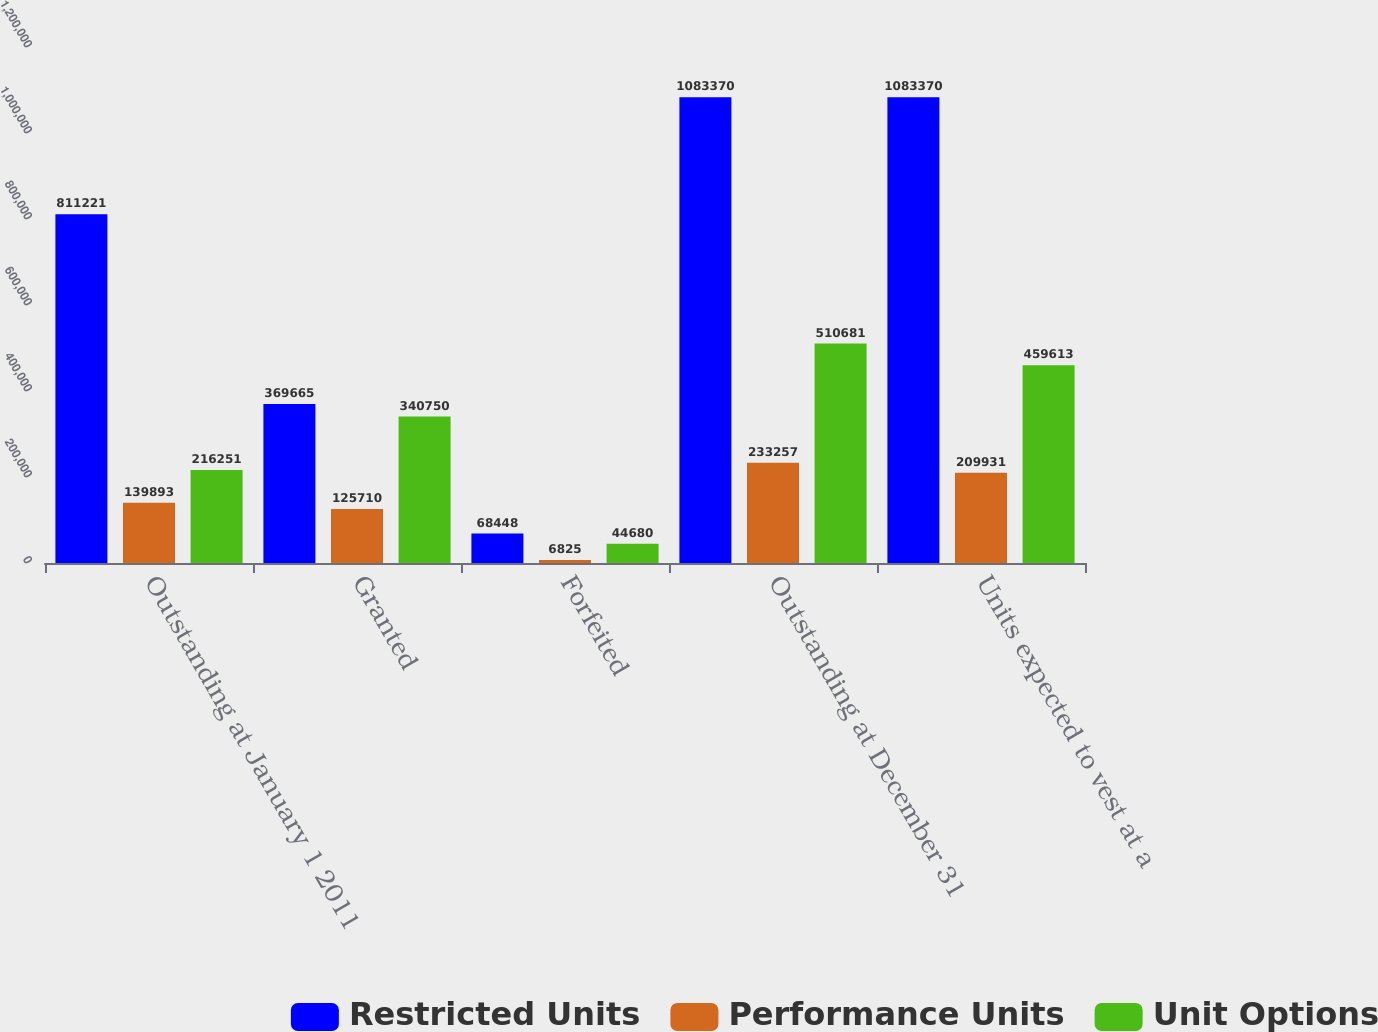Convert chart. <chart><loc_0><loc_0><loc_500><loc_500><stacked_bar_chart><ecel><fcel>Outstanding at January 1 2011<fcel>Granted<fcel>Forfeited<fcel>Outstanding at December 31<fcel>Units expected to vest at a<nl><fcel>Restricted Units<fcel>811221<fcel>369665<fcel>68448<fcel>1.08337e+06<fcel>1.08337e+06<nl><fcel>Performance Units<fcel>139893<fcel>125710<fcel>6825<fcel>233257<fcel>209931<nl><fcel>Unit Options<fcel>216251<fcel>340750<fcel>44680<fcel>510681<fcel>459613<nl></chart> 